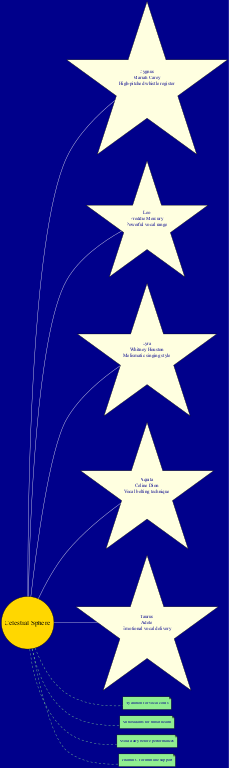What constellation is associated with Mariah Carey? The diagram lists Mariah Carey under the constellation Cygnus. This can be found directly by looking for her name in the respective node connected to the center.
Answer: Cygnus How many constellations are shown in the diagram? By counting the nodes that represent constellations, we see there are five (Cygnus, Leo, Lyra, Aquila, Taurus). Each of these is connected to the center node, indicating they are all part of the celestial sphere.
Answer: 5 What vocal feature is associated with Whitney Houston? The diagram indicates that Whitney Houston is connected to the constellation Lyra, showcasing her melismatic singing style as her notable vocal feature.
Answer: Melismatic singing style Which constellation represents Freddie Mercury? Freddie Mercury is represented by the constellation Leo, which can be identified by finding his name in the corresponding node linked directly from the center.
Answer: Leo What nutritional tip mentions throat health? Among the nutritional tips displayed in the diagram, the tip that directly mentions throat health is “Antioxidants for throat health.” This is found by checking the connection that pertains to nutritional information.
Answer: Antioxidants for throat health Which singer is associated with the emotional vocal delivery feature? The diagram connects Adele with the constellation Taurus, and her vocal feature is described specifically as emotional vocal delivery, making this link clear when examining the nodes.
Answer: Adele What is the connection style for the nutritional tips in the diagram? The nutritional tips are connected to the central celestial sphere node with dashed lines. This can be observed by examining how the tips are visually linked to the center.
Answer: Dashed Which constellation features Celine Dion? Celine Dion is associated with the constellation Aquila in the diagram. This association is made by looking for her name further linked to the appropriate constellation node.
Answer: Aquila What are the four main nutritional tips for vocal health shown? The diagram features four main nutritional tips which are hydration for vocal cords, antioxidants for throat health, avoid dairy before performances, and vitamin C for immune support. These are clearly listed as connected notes.
Answer: Hydration for vocal cords, Antioxidants for throat health, Avoid dairy before performances, Vitamin C for immune support 